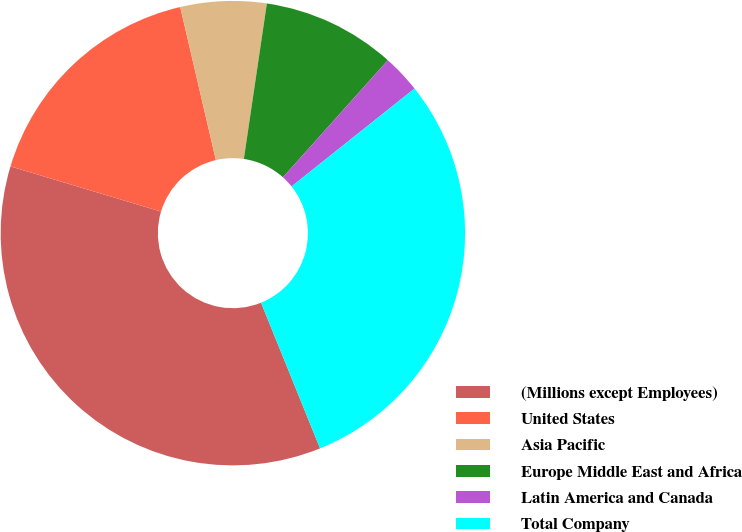<chart> <loc_0><loc_0><loc_500><loc_500><pie_chart><fcel>(Millions except Employees)<fcel>United States<fcel>Asia Pacific<fcel>Europe Middle East and Africa<fcel>Latin America and Canada<fcel>Total Company<nl><fcel>35.77%<fcel>16.72%<fcel>5.98%<fcel>9.29%<fcel>2.67%<fcel>29.58%<nl></chart> 